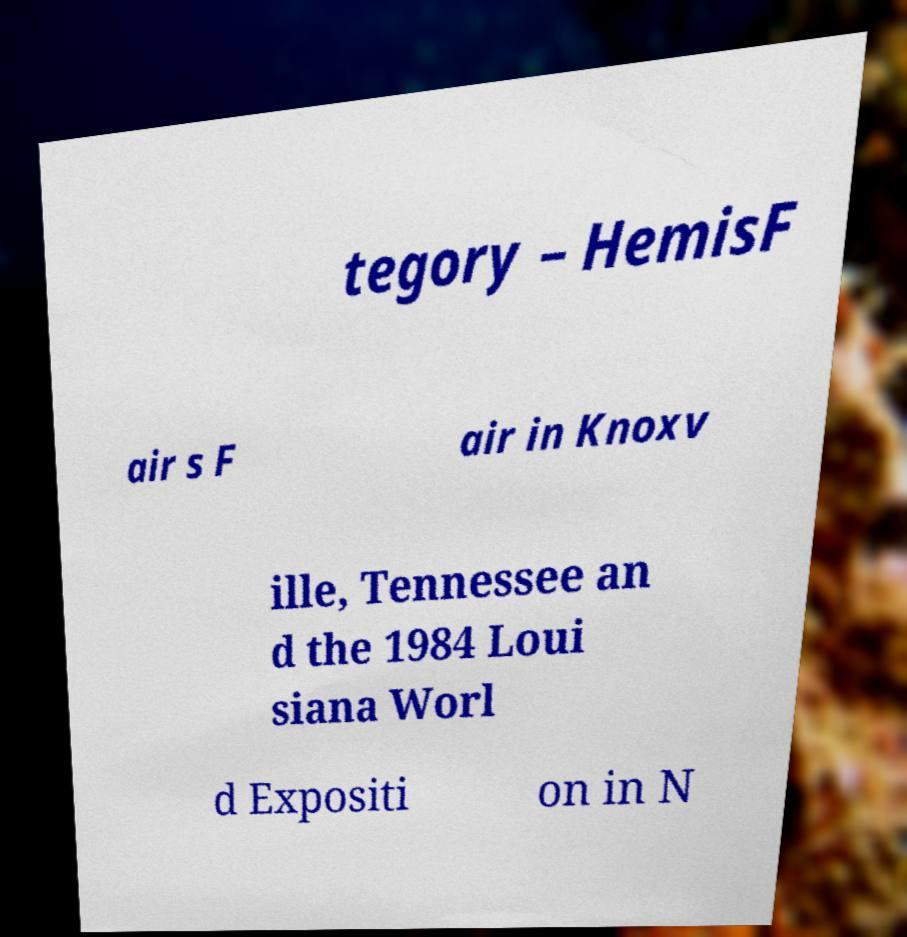Can you accurately transcribe the text from the provided image for me? tegory – HemisF air s F air in Knoxv ille, Tennessee an d the 1984 Loui siana Worl d Expositi on in N 